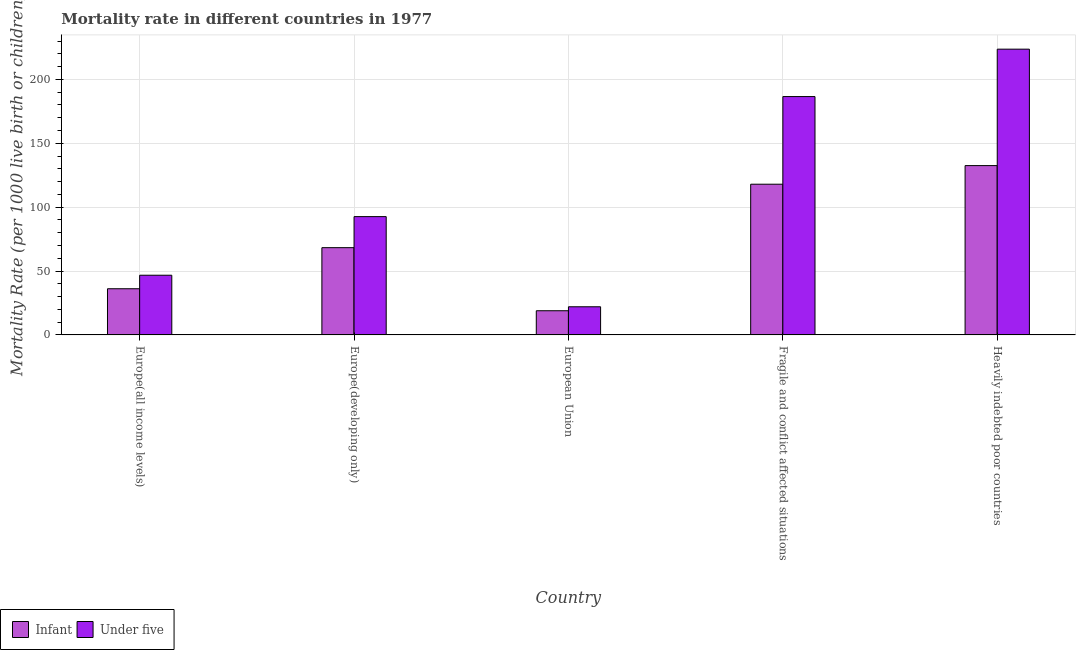How many bars are there on the 3rd tick from the right?
Keep it short and to the point. 2. What is the label of the 4th group of bars from the left?
Give a very brief answer. Fragile and conflict affected situations. What is the under-5 mortality rate in European Union?
Offer a terse response. 22.03. Across all countries, what is the maximum infant mortality rate?
Provide a short and direct response. 132.53. Across all countries, what is the minimum under-5 mortality rate?
Ensure brevity in your answer.  22.03. In which country was the under-5 mortality rate maximum?
Your answer should be compact. Heavily indebted poor countries. In which country was the infant mortality rate minimum?
Your answer should be very brief. European Union. What is the total under-5 mortality rate in the graph?
Your answer should be very brief. 571.62. What is the difference between the under-5 mortality rate in Europe(all income levels) and that in Europe(developing only)?
Provide a short and direct response. -45.87. What is the difference between the under-5 mortality rate in European Union and the infant mortality rate in Europe(developing only)?
Provide a short and direct response. -46.27. What is the average infant mortality rate per country?
Provide a short and direct response. 74.78. What is the difference between the infant mortality rate and under-5 mortality rate in Heavily indebted poor countries?
Ensure brevity in your answer.  -91.15. What is the ratio of the under-5 mortality rate in European Union to that in Fragile and conflict affected situations?
Your answer should be very brief. 0.12. Is the under-5 mortality rate in European Union less than that in Fragile and conflict affected situations?
Keep it short and to the point. Yes. Is the difference between the under-5 mortality rate in Europe(all income levels) and European Union greater than the difference between the infant mortality rate in Europe(all income levels) and European Union?
Your answer should be compact. Yes. What is the difference between the highest and the second highest infant mortality rate?
Provide a short and direct response. 14.56. What is the difference between the highest and the lowest infant mortality rate?
Keep it short and to the point. 113.61. In how many countries, is the under-5 mortality rate greater than the average under-5 mortality rate taken over all countries?
Your answer should be very brief. 2. Is the sum of the under-5 mortality rate in European Union and Fragile and conflict affected situations greater than the maximum infant mortality rate across all countries?
Your answer should be very brief. Yes. What does the 1st bar from the left in European Union represents?
Provide a short and direct response. Infant. What does the 2nd bar from the right in European Union represents?
Make the answer very short. Infant. Are all the bars in the graph horizontal?
Your response must be concise. No. Are the values on the major ticks of Y-axis written in scientific E-notation?
Offer a very short reply. No. Where does the legend appear in the graph?
Your answer should be compact. Bottom left. What is the title of the graph?
Provide a succinct answer. Mortality rate in different countries in 1977. Does "Male entrants" appear as one of the legend labels in the graph?
Give a very brief answer. No. What is the label or title of the X-axis?
Offer a very short reply. Country. What is the label or title of the Y-axis?
Provide a short and direct response. Mortality Rate (per 1000 live birth or children). What is the Mortality Rate (per 1000 live birth or children) of Infant in Europe(all income levels)?
Keep it short and to the point. 36.15. What is the Mortality Rate (per 1000 live birth or children) of Under five in Europe(all income levels)?
Make the answer very short. 46.73. What is the Mortality Rate (per 1000 live birth or children) in Infant in Europe(developing only)?
Your answer should be very brief. 68.3. What is the Mortality Rate (per 1000 live birth or children) in Under five in Europe(developing only)?
Provide a short and direct response. 92.6. What is the Mortality Rate (per 1000 live birth or children) of Infant in European Union?
Your response must be concise. 18.92. What is the Mortality Rate (per 1000 live birth or children) in Under five in European Union?
Your response must be concise. 22.03. What is the Mortality Rate (per 1000 live birth or children) in Infant in Fragile and conflict affected situations?
Your answer should be very brief. 117.97. What is the Mortality Rate (per 1000 live birth or children) of Under five in Fragile and conflict affected situations?
Make the answer very short. 186.58. What is the Mortality Rate (per 1000 live birth or children) of Infant in Heavily indebted poor countries?
Your answer should be very brief. 132.53. What is the Mortality Rate (per 1000 live birth or children) of Under five in Heavily indebted poor countries?
Give a very brief answer. 223.69. Across all countries, what is the maximum Mortality Rate (per 1000 live birth or children) in Infant?
Offer a terse response. 132.53. Across all countries, what is the maximum Mortality Rate (per 1000 live birth or children) in Under five?
Your answer should be compact. 223.69. Across all countries, what is the minimum Mortality Rate (per 1000 live birth or children) in Infant?
Your answer should be very brief. 18.92. Across all countries, what is the minimum Mortality Rate (per 1000 live birth or children) of Under five?
Offer a very short reply. 22.03. What is the total Mortality Rate (per 1000 live birth or children) in Infant in the graph?
Ensure brevity in your answer.  373.88. What is the total Mortality Rate (per 1000 live birth or children) of Under five in the graph?
Your answer should be compact. 571.62. What is the difference between the Mortality Rate (per 1000 live birth or children) of Infant in Europe(all income levels) and that in Europe(developing only)?
Keep it short and to the point. -32.15. What is the difference between the Mortality Rate (per 1000 live birth or children) in Under five in Europe(all income levels) and that in Europe(developing only)?
Your answer should be compact. -45.87. What is the difference between the Mortality Rate (per 1000 live birth or children) in Infant in Europe(all income levels) and that in European Union?
Your answer should be compact. 17.22. What is the difference between the Mortality Rate (per 1000 live birth or children) of Under five in Europe(all income levels) and that in European Union?
Offer a very short reply. 24.7. What is the difference between the Mortality Rate (per 1000 live birth or children) in Infant in Europe(all income levels) and that in Fragile and conflict affected situations?
Offer a terse response. -81.83. What is the difference between the Mortality Rate (per 1000 live birth or children) in Under five in Europe(all income levels) and that in Fragile and conflict affected situations?
Your answer should be very brief. -139.85. What is the difference between the Mortality Rate (per 1000 live birth or children) of Infant in Europe(all income levels) and that in Heavily indebted poor countries?
Make the answer very short. -96.39. What is the difference between the Mortality Rate (per 1000 live birth or children) of Under five in Europe(all income levels) and that in Heavily indebted poor countries?
Keep it short and to the point. -176.96. What is the difference between the Mortality Rate (per 1000 live birth or children) of Infant in Europe(developing only) and that in European Union?
Your answer should be very brief. 49.38. What is the difference between the Mortality Rate (per 1000 live birth or children) in Under five in Europe(developing only) and that in European Union?
Your response must be concise. 70.57. What is the difference between the Mortality Rate (per 1000 live birth or children) of Infant in Europe(developing only) and that in Fragile and conflict affected situations?
Your answer should be compact. -49.67. What is the difference between the Mortality Rate (per 1000 live birth or children) of Under five in Europe(developing only) and that in Fragile and conflict affected situations?
Give a very brief answer. -93.98. What is the difference between the Mortality Rate (per 1000 live birth or children) of Infant in Europe(developing only) and that in Heavily indebted poor countries?
Your response must be concise. -64.23. What is the difference between the Mortality Rate (per 1000 live birth or children) of Under five in Europe(developing only) and that in Heavily indebted poor countries?
Provide a short and direct response. -131.09. What is the difference between the Mortality Rate (per 1000 live birth or children) in Infant in European Union and that in Fragile and conflict affected situations?
Your answer should be compact. -99.05. What is the difference between the Mortality Rate (per 1000 live birth or children) of Under five in European Union and that in Fragile and conflict affected situations?
Give a very brief answer. -164.55. What is the difference between the Mortality Rate (per 1000 live birth or children) in Infant in European Union and that in Heavily indebted poor countries?
Ensure brevity in your answer.  -113.61. What is the difference between the Mortality Rate (per 1000 live birth or children) in Under five in European Union and that in Heavily indebted poor countries?
Ensure brevity in your answer.  -201.66. What is the difference between the Mortality Rate (per 1000 live birth or children) in Infant in Fragile and conflict affected situations and that in Heavily indebted poor countries?
Your answer should be very brief. -14.56. What is the difference between the Mortality Rate (per 1000 live birth or children) of Under five in Fragile and conflict affected situations and that in Heavily indebted poor countries?
Your answer should be very brief. -37.11. What is the difference between the Mortality Rate (per 1000 live birth or children) in Infant in Europe(all income levels) and the Mortality Rate (per 1000 live birth or children) in Under five in Europe(developing only)?
Offer a terse response. -56.45. What is the difference between the Mortality Rate (per 1000 live birth or children) in Infant in Europe(all income levels) and the Mortality Rate (per 1000 live birth or children) in Under five in European Union?
Your response must be concise. 14.12. What is the difference between the Mortality Rate (per 1000 live birth or children) in Infant in Europe(all income levels) and the Mortality Rate (per 1000 live birth or children) in Under five in Fragile and conflict affected situations?
Your response must be concise. -150.43. What is the difference between the Mortality Rate (per 1000 live birth or children) of Infant in Europe(all income levels) and the Mortality Rate (per 1000 live birth or children) of Under five in Heavily indebted poor countries?
Keep it short and to the point. -187.54. What is the difference between the Mortality Rate (per 1000 live birth or children) in Infant in Europe(developing only) and the Mortality Rate (per 1000 live birth or children) in Under five in European Union?
Your answer should be compact. 46.27. What is the difference between the Mortality Rate (per 1000 live birth or children) of Infant in Europe(developing only) and the Mortality Rate (per 1000 live birth or children) of Under five in Fragile and conflict affected situations?
Provide a succinct answer. -118.28. What is the difference between the Mortality Rate (per 1000 live birth or children) of Infant in Europe(developing only) and the Mortality Rate (per 1000 live birth or children) of Under five in Heavily indebted poor countries?
Provide a succinct answer. -155.39. What is the difference between the Mortality Rate (per 1000 live birth or children) in Infant in European Union and the Mortality Rate (per 1000 live birth or children) in Under five in Fragile and conflict affected situations?
Provide a short and direct response. -167.66. What is the difference between the Mortality Rate (per 1000 live birth or children) in Infant in European Union and the Mortality Rate (per 1000 live birth or children) in Under five in Heavily indebted poor countries?
Your answer should be compact. -204.77. What is the difference between the Mortality Rate (per 1000 live birth or children) in Infant in Fragile and conflict affected situations and the Mortality Rate (per 1000 live birth or children) in Under five in Heavily indebted poor countries?
Provide a succinct answer. -105.72. What is the average Mortality Rate (per 1000 live birth or children) of Infant per country?
Provide a short and direct response. 74.78. What is the average Mortality Rate (per 1000 live birth or children) of Under five per country?
Provide a short and direct response. 114.32. What is the difference between the Mortality Rate (per 1000 live birth or children) in Infant and Mortality Rate (per 1000 live birth or children) in Under five in Europe(all income levels)?
Your response must be concise. -10.58. What is the difference between the Mortality Rate (per 1000 live birth or children) of Infant and Mortality Rate (per 1000 live birth or children) of Under five in Europe(developing only)?
Offer a terse response. -24.3. What is the difference between the Mortality Rate (per 1000 live birth or children) of Infant and Mortality Rate (per 1000 live birth or children) of Under five in European Union?
Your answer should be compact. -3.1. What is the difference between the Mortality Rate (per 1000 live birth or children) in Infant and Mortality Rate (per 1000 live birth or children) in Under five in Fragile and conflict affected situations?
Give a very brief answer. -68.61. What is the difference between the Mortality Rate (per 1000 live birth or children) in Infant and Mortality Rate (per 1000 live birth or children) in Under five in Heavily indebted poor countries?
Keep it short and to the point. -91.15. What is the ratio of the Mortality Rate (per 1000 live birth or children) of Infant in Europe(all income levels) to that in Europe(developing only)?
Keep it short and to the point. 0.53. What is the ratio of the Mortality Rate (per 1000 live birth or children) of Under five in Europe(all income levels) to that in Europe(developing only)?
Provide a short and direct response. 0.5. What is the ratio of the Mortality Rate (per 1000 live birth or children) of Infant in Europe(all income levels) to that in European Union?
Give a very brief answer. 1.91. What is the ratio of the Mortality Rate (per 1000 live birth or children) of Under five in Europe(all income levels) to that in European Union?
Ensure brevity in your answer.  2.12. What is the ratio of the Mortality Rate (per 1000 live birth or children) of Infant in Europe(all income levels) to that in Fragile and conflict affected situations?
Your answer should be very brief. 0.31. What is the ratio of the Mortality Rate (per 1000 live birth or children) in Under five in Europe(all income levels) to that in Fragile and conflict affected situations?
Ensure brevity in your answer.  0.25. What is the ratio of the Mortality Rate (per 1000 live birth or children) of Infant in Europe(all income levels) to that in Heavily indebted poor countries?
Ensure brevity in your answer.  0.27. What is the ratio of the Mortality Rate (per 1000 live birth or children) in Under five in Europe(all income levels) to that in Heavily indebted poor countries?
Offer a very short reply. 0.21. What is the ratio of the Mortality Rate (per 1000 live birth or children) of Infant in Europe(developing only) to that in European Union?
Your response must be concise. 3.61. What is the ratio of the Mortality Rate (per 1000 live birth or children) in Under five in Europe(developing only) to that in European Union?
Your response must be concise. 4.2. What is the ratio of the Mortality Rate (per 1000 live birth or children) in Infant in Europe(developing only) to that in Fragile and conflict affected situations?
Your answer should be compact. 0.58. What is the ratio of the Mortality Rate (per 1000 live birth or children) in Under five in Europe(developing only) to that in Fragile and conflict affected situations?
Give a very brief answer. 0.5. What is the ratio of the Mortality Rate (per 1000 live birth or children) in Infant in Europe(developing only) to that in Heavily indebted poor countries?
Offer a very short reply. 0.52. What is the ratio of the Mortality Rate (per 1000 live birth or children) of Under five in Europe(developing only) to that in Heavily indebted poor countries?
Keep it short and to the point. 0.41. What is the ratio of the Mortality Rate (per 1000 live birth or children) of Infant in European Union to that in Fragile and conflict affected situations?
Offer a very short reply. 0.16. What is the ratio of the Mortality Rate (per 1000 live birth or children) in Under five in European Union to that in Fragile and conflict affected situations?
Provide a short and direct response. 0.12. What is the ratio of the Mortality Rate (per 1000 live birth or children) of Infant in European Union to that in Heavily indebted poor countries?
Keep it short and to the point. 0.14. What is the ratio of the Mortality Rate (per 1000 live birth or children) of Under five in European Union to that in Heavily indebted poor countries?
Offer a terse response. 0.1. What is the ratio of the Mortality Rate (per 1000 live birth or children) in Infant in Fragile and conflict affected situations to that in Heavily indebted poor countries?
Your answer should be very brief. 0.89. What is the ratio of the Mortality Rate (per 1000 live birth or children) in Under five in Fragile and conflict affected situations to that in Heavily indebted poor countries?
Your answer should be very brief. 0.83. What is the difference between the highest and the second highest Mortality Rate (per 1000 live birth or children) in Infant?
Keep it short and to the point. 14.56. What is the difference between the highest and the second highest Mortality Rate (per 1000 live birth or children) in Under five?
Offer a terse response. 37.11. What is the difference between the highest and the lowest Mortality Rate (per 1000 live birth or children) of Infant?
Offer a terse response. 113.61. What is the difference between the highest and the lowest Mortality Rate (per 1000 live birth or children) of Under five?
Ensure brevity in your answer.  201.66. 